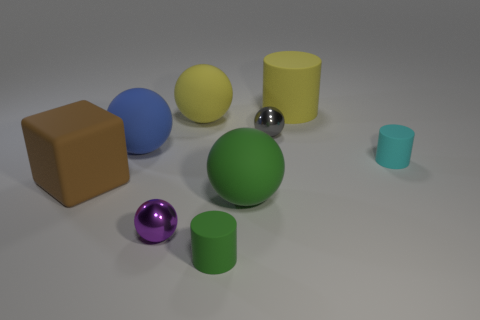Is there any other thing that has the same size as the brown matte object?
Provide a succinct answer. Yes. How many large blue objects are right of the small ball on the right side of the yellow thing that is on the left side of the large green matte sphere?
Provide a succinct answer. 0. Do the tiny gray metallic thing and the small purple metal object have the same shape?
Keep it short and to the point. Yes. Do the big cube that is behind the large green thing and the tiny purple object that is on the right side of the large blue sphere have the same material?
Ensure brevity in your answer.  No. How many objects are either big cylinders on the right side of the small green cylinder or tiny metallic objects that are on the left side of the small gray shiny thing?
Offer a very short reply. 2. Are there any other things that have the same shape as the tiny purple shiny thing?
Your answer should be very brief. Yes. How many small cyan rubber cubes are there?
Ensure brevity in your answer.  0. Are there any blue cylinders of the same size as the yellow cylinder?
Offer a terse response. No. Are the big blue thing and the sphere in front of the big green sphere made of the same material?
Your answer should be very brief. No. What is the material of the large ball that is behind the big blue rubber sphere?
Provide a succinct answer. Rubber. 